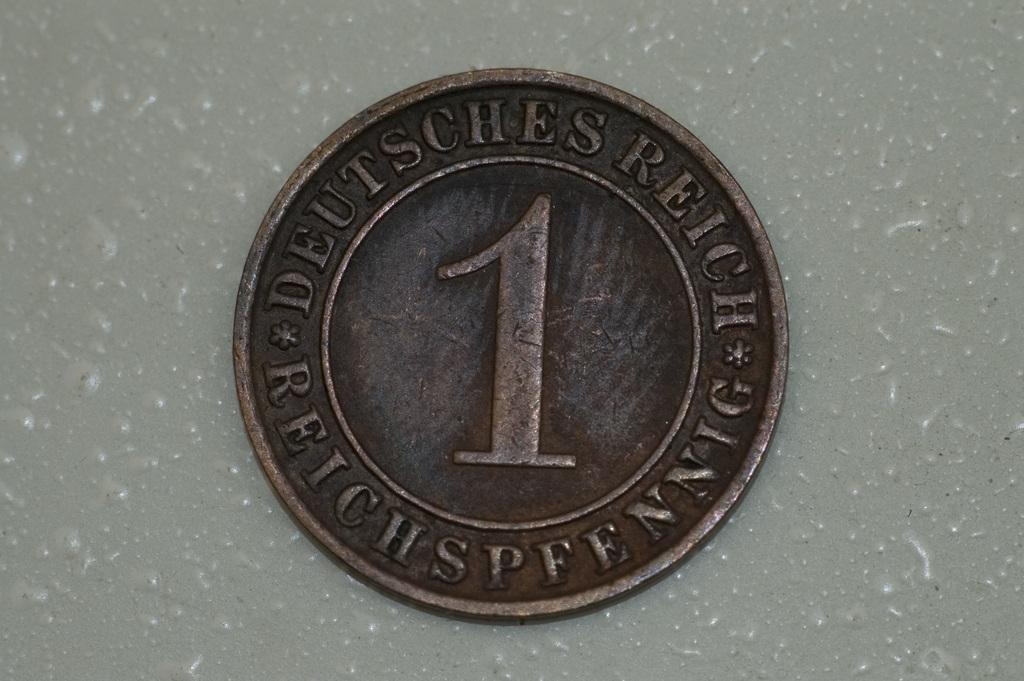What object can be seen on the surface in the image? There is a coin on the surface in the image. What type of approval does the mother give in the image? There is no mother or approval present in the image; it only features a coin on the surface. 